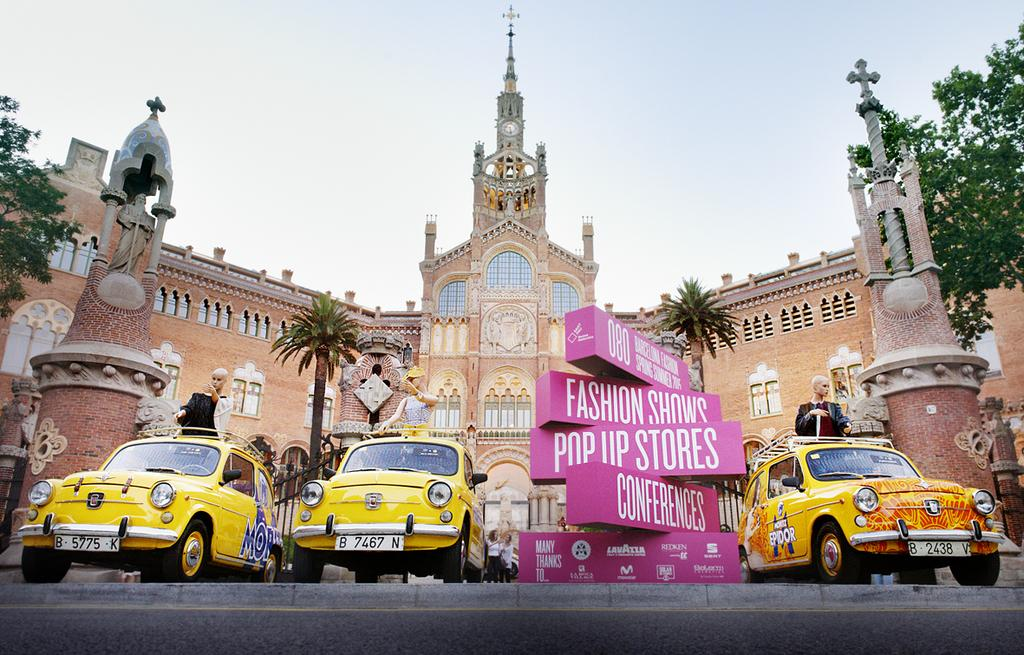<image>
Provide a brief description of the given image. Two yellow cars between signs which read Pop Up Stores and Conferences. 